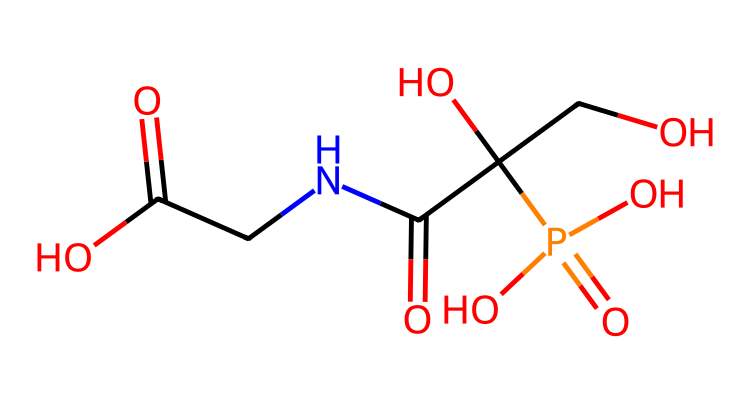What is the molecular formula of glyphosate? To determine the molecular formula from the SMILES, count the total number of each type of atom present. The given SMILES contains: 3 carbon (C), 6 hydrogen (H), 3 oxygen (O), 1 nitrogen (N), and 1 phosphorus (P) atom. Thus, the molecular formula is C3H8N5O5P.
Answer: C3H8N5O5P How many oxygen atoms are there in glyphosate? Looking at the SMILES representation, we can count the number of oxygen atoms present. There are five instances of 'O' throughout the structure. Therefore, glyphosate contains five oxygen atoms.
Answer: 5 What functional groups are present in glyphosate? Analyzing the SMILES structure reveals the presence of multiple functional groups: a phosphoryl group (-PO4) and a carboxylic acid group (-COOH). Both are identifiable based on their typical structures.
Answer: phosphoryl and carboxylic acid Which part of glyphosate is responsible for its herbicidal action? The specific structural features of glyphosate, such as the phosphonate group (signified by the presence of phosphorus and oxygen), are critical for its herbicidal properties as they disrupt shikimic acid pathway in plants. Thus, the phosphonate group is key for glyphosate’s function as a herbicide.
Answer: phosphonate group What is the total number of rings in glyphosate's structure? Upon examining the SMILES representation, we note that there are no cyclic structures. All components appear to be straight-chain or branched structures. Thus, glyphosate has zero rings in its structure.
Answer: 0 